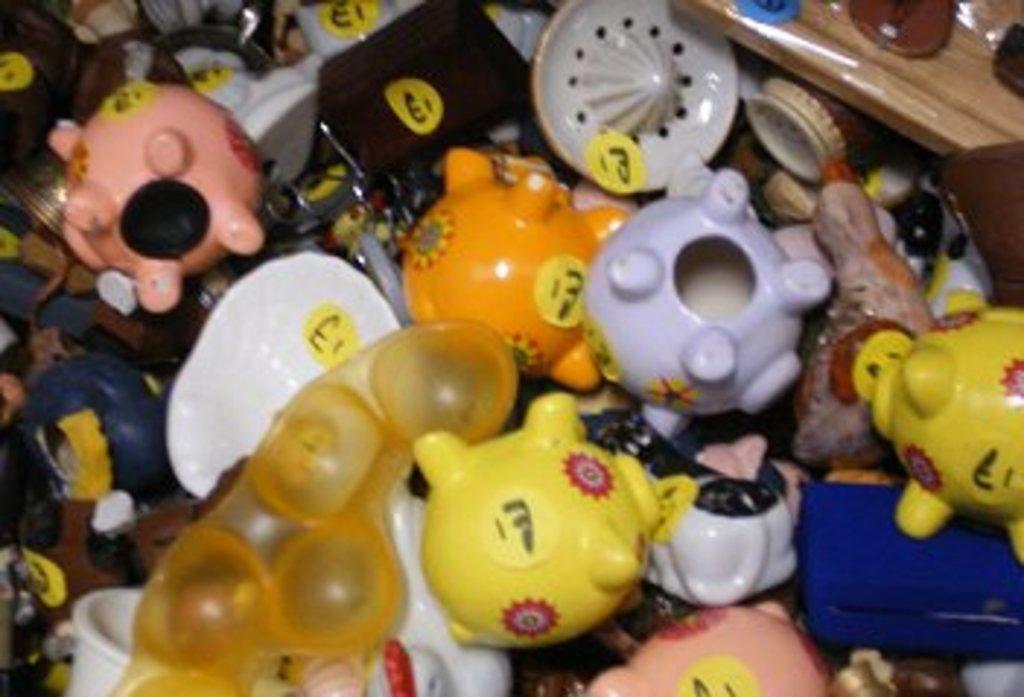How would you summarize this image in a sentence or two? In this picture I can see the toys. 